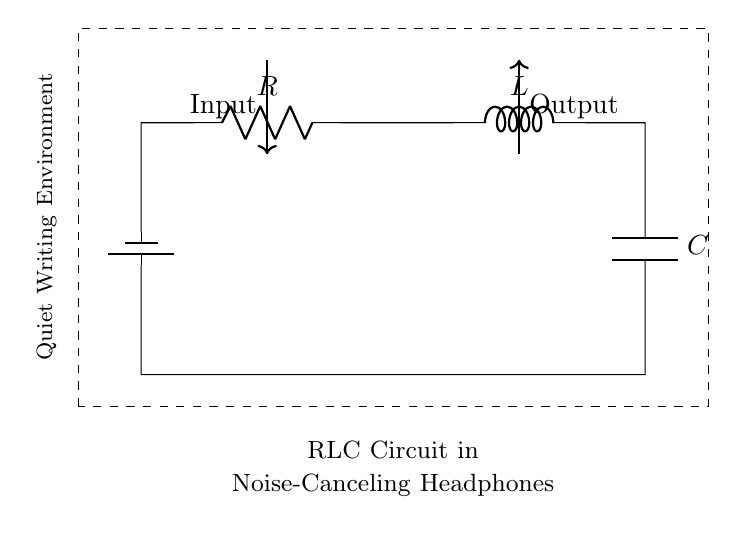What components are present in this circuit? The circuit contains a resistor, inductor, and capacitor, as labeled in the diagram.
Answer: resistor, inductor, capacitor What is the purpose of the battery in this circuit? The battery provides the necessary voltage to drive the current through the RLC circuit and operate the headphones.
Answer: voltage supply What does "R" represent in this circuit? "R" represents the resistance, which limits the current flow and determines how much voltage drop occurs in the circuit.
Answer: resistance What is the significance of the dashed rectangle in the diagram? The dashed rectangle indicates the boundaries of the circuit's application, specifically showing that it relates to creating a quiet writing environment.
Answer: circuit application boundaries How do the resistor, inductor, and capacitor interact in this circuit to reduce noise? The resistor dissipates energy as heat, the inductor opposes changes in current, and the capacitor stores and releases energy, working together to filter out noise frequencies.
Answer: noise reduction filter What would happen if the capacitor was removed from this circuit? Without the capacitor, the circuit would lose its ability to store and release energy, impairing its effectiveness in filtering out unwanted noise frequencies and disrupting sound quality.
Answer: impaired noise filtering How does the arrangement of the components affect the circuit's resonance? The arrangement of R, L, and C determines the circuit's resonant frequency, at which it can effectively cancel out particular noise frequencies, creating a desirable acoustic environment.
Answer: affects resonant frequency 